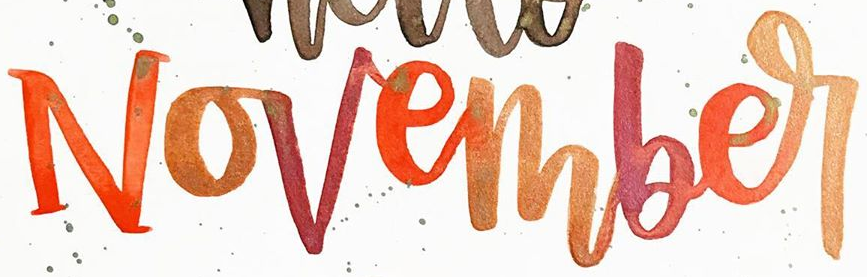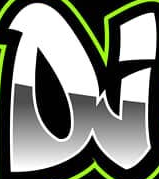Read the text from these images in sequence, separated by a semicolon. November; DJ 